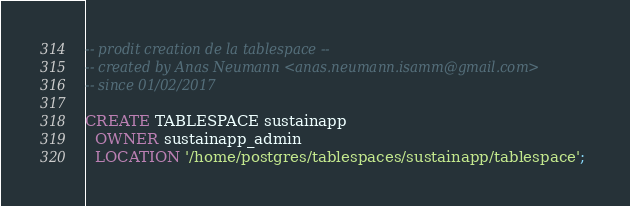Convert code to text. <code><loc_0><loc_0><loc_500><loc_500><_SQL_>-- prodit creation de la tablespace --
-- created by Anas Neumann <anas.neumann.isamm@gmail.com>
-- since 01/02/2017

CREATE TABLESPACE sustainapp
  OWNER sustainapp_admin
  LOCATION '/home/postgres/tablespaces/sustainapp/tablespace';
</code> 